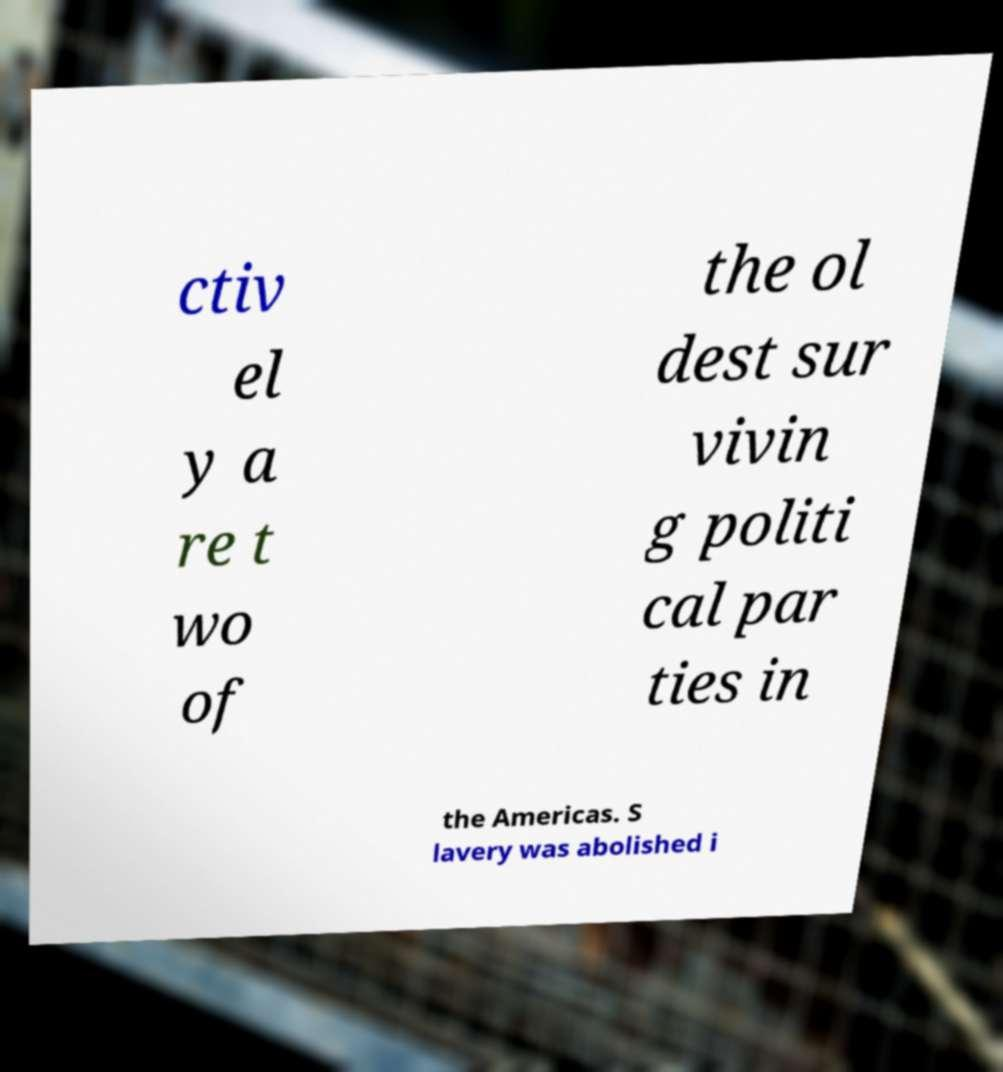Can you accurately transcribe the text from the provided image for me? ctiv el y a re t wo of the ol dest sur vivin g politi cal par ties in the Americas. S lavery was abolished i 